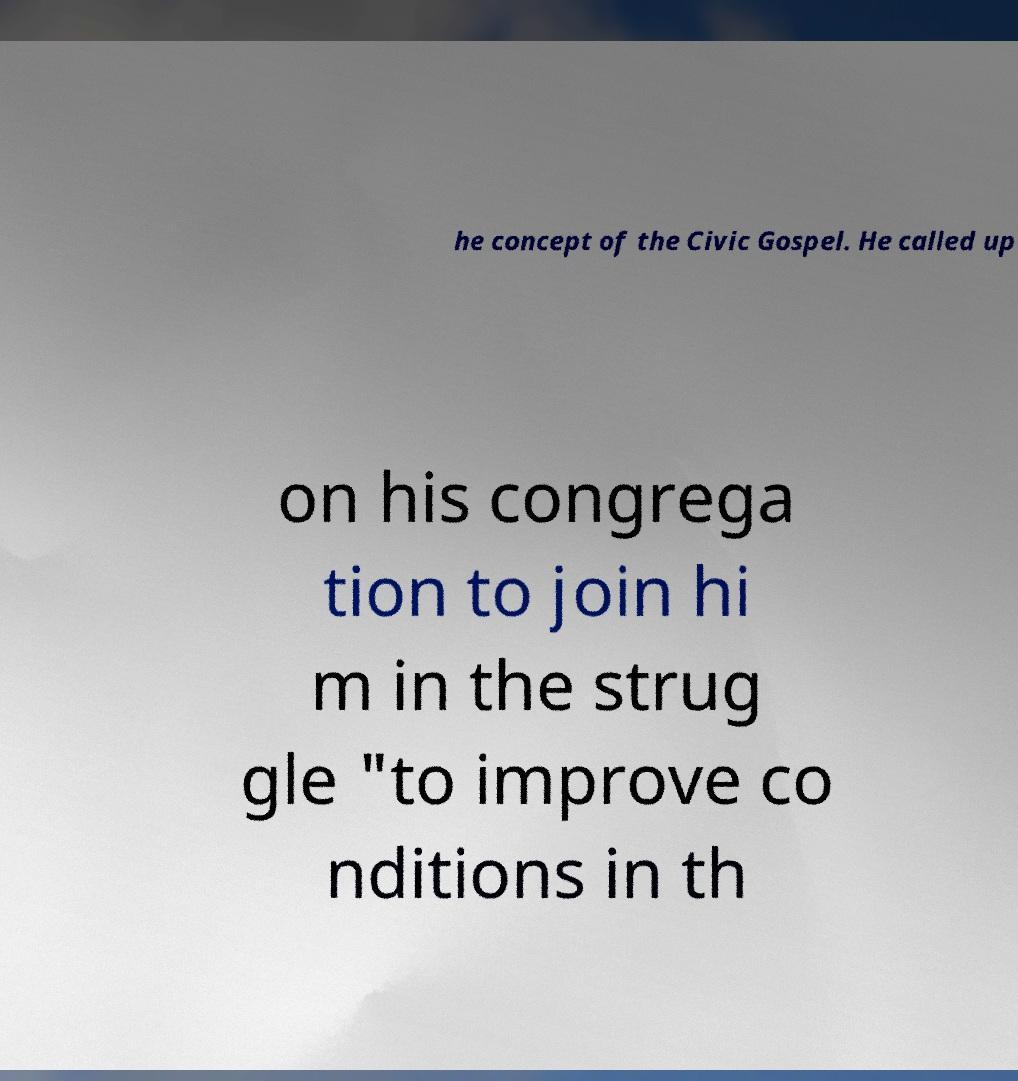Please identify and transcribe the text found in this image. he concept of the Civic Gospel. He called up on his congrega tion to join hi m in the strug gle "to improve co nditions in th 